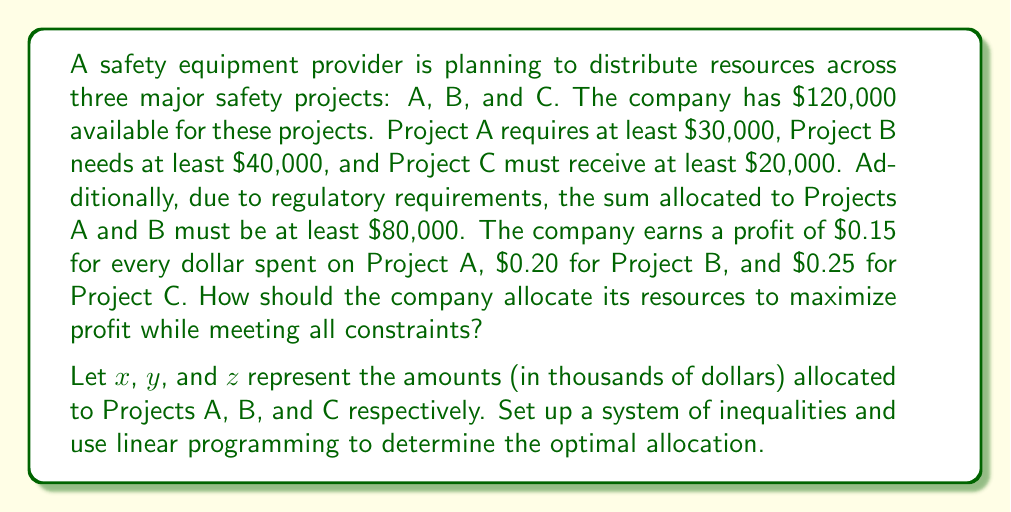Solve this math problem. Let's approach this step-by-step:

1) First, we need to set up our system of inequalities based on the given constraints:

   $$x \geq 30$$ (Project A needs at least $30,000)
   $$y \geq 40$$ (Project B needs at least $40,000)
   $$z \geq 20$$ (Project C needs at least $20,000)
   $$x + y \geq 80$$ (Sum of A and B must be at least $80,000)
   $$x + y + z = 120$$ (Total budget is $120,000)

2) Our objective function to maximize profit is:

   $$P = 0.15x + 0.20y + 0.25z$$

3) We can solve this using the simplex method, but we can also reason through it:

   - We need to allocate as much as possible to Project C (highest profit margin), but it needs at least $20,000.
   - Projects A and B combined need at least $80,000.
   - Given the profit margins, we should allocate the minimum to A ($30,000) and the rest to B ($50,000) to meet the $80,000 requirement.

4) This leaves us with:

   $$x = 30$$
   $$y = 50$$
   $$z = 40$$

5) We can verify that this satisfies all constraints:

   $$30 \geq 30$$ (true)
   $$50 \geq 40$$ (true)
   $$40 \geq 20$$ (true)
   $$30 + 50 = 80 \geq 80$$ (true)
   $$30 + 50 + 40 = 120$$ (true)

6) The maximum profit is thus:

   $$P = 0.15(30) + 0.20(50) + 0.25(40) = 4.5 + 10 + 10 = 24.5$$

Therefore, the optimal allocation is $30,000 to Project A, $50,000 to Project B, and $40,000 to Project C, yielding a maximum profit of $24,500.
Answer: The optimal allocation is:
Project A: $30,000
Project B: $50,000
Project C: $40,000
Maximum profit: $24,500 